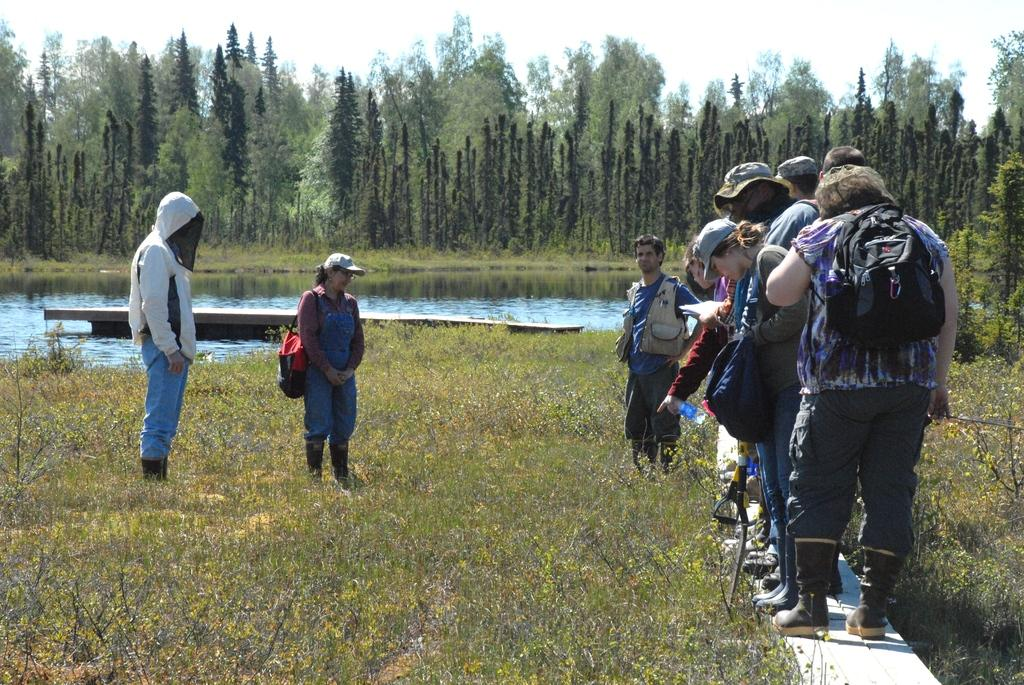What type of vegetation is present on the ground in the front of the image? There is grass on the ground in the front of the image. What can be seen in the center of the image? There is a group of persons standing in the center of the image. What is visible in the background of the image? There is water and trees visible in the background of the image. How many faces can be seen on the water in the background of the image? There are no faces visible on the water in the background of the image. What is the value of the trees in the background of the image? The value of the trees cannot be determined from the image, as they are not for sale or associated with any monetary value. 